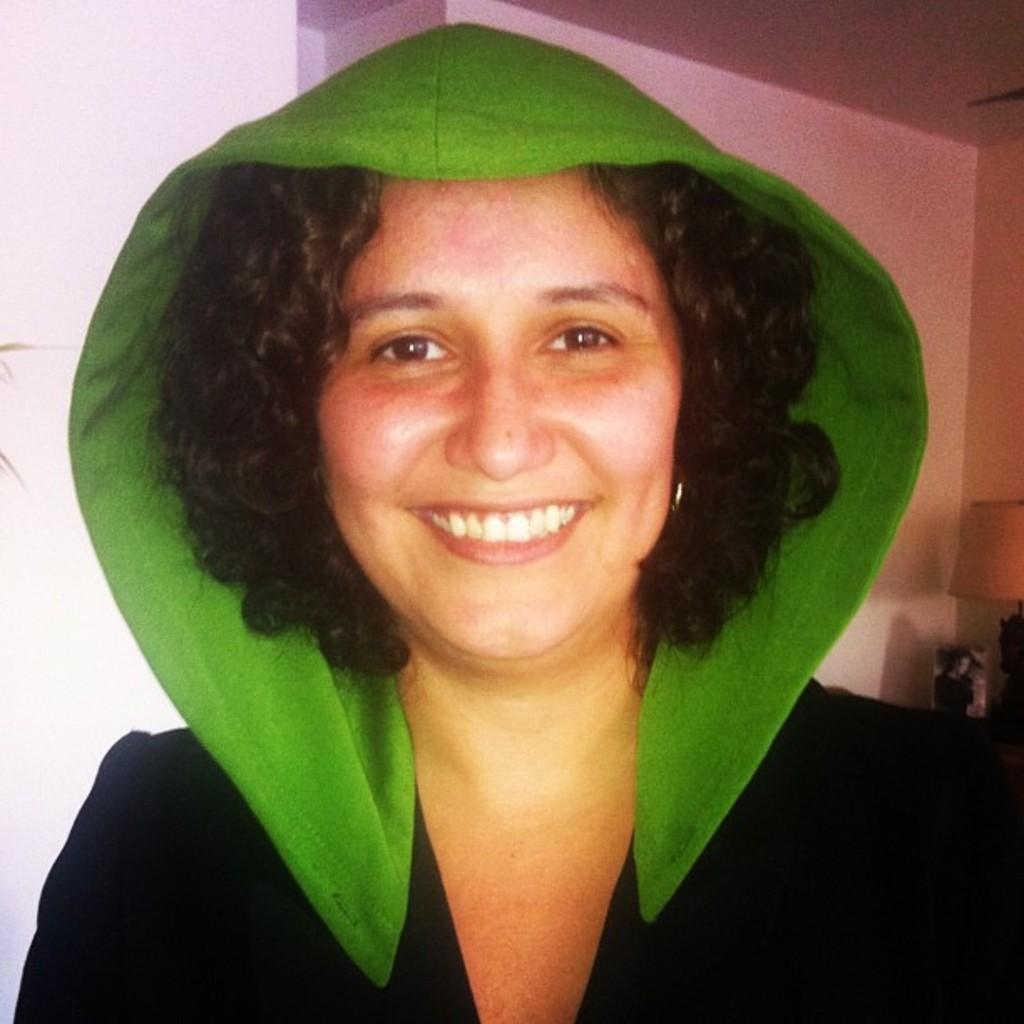In one or two sentences, can you explain what this image depicts? In this image there is a woman standing and smiling, behind her there is a table with lamp. 